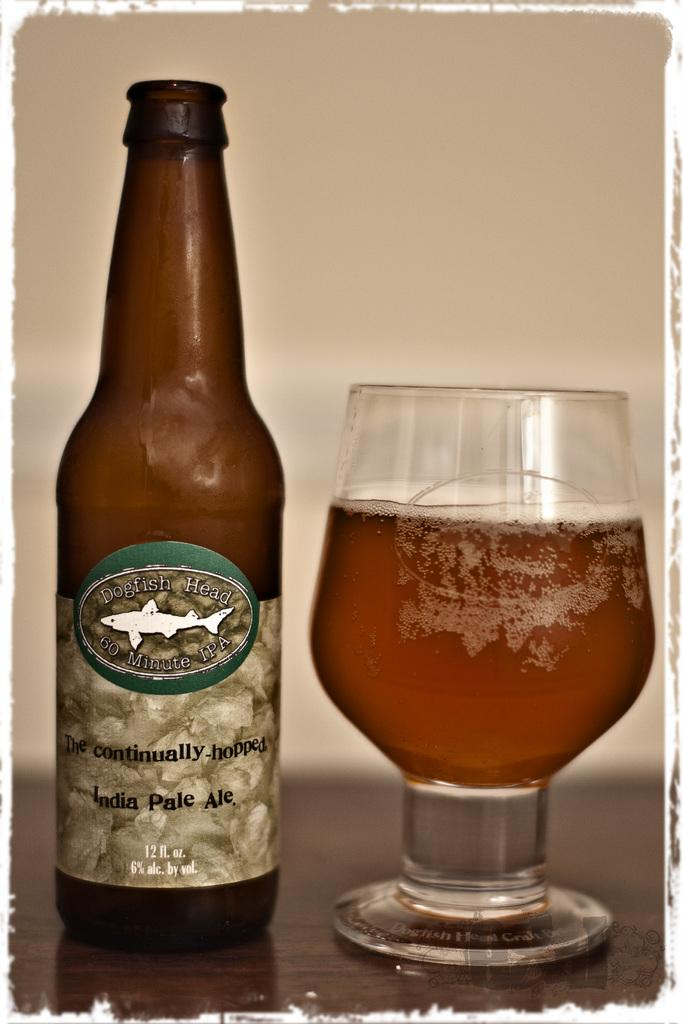<image>
Present a compact description of the photo's key features. A bottle with a fish on it is labeled Dogfish Head. 